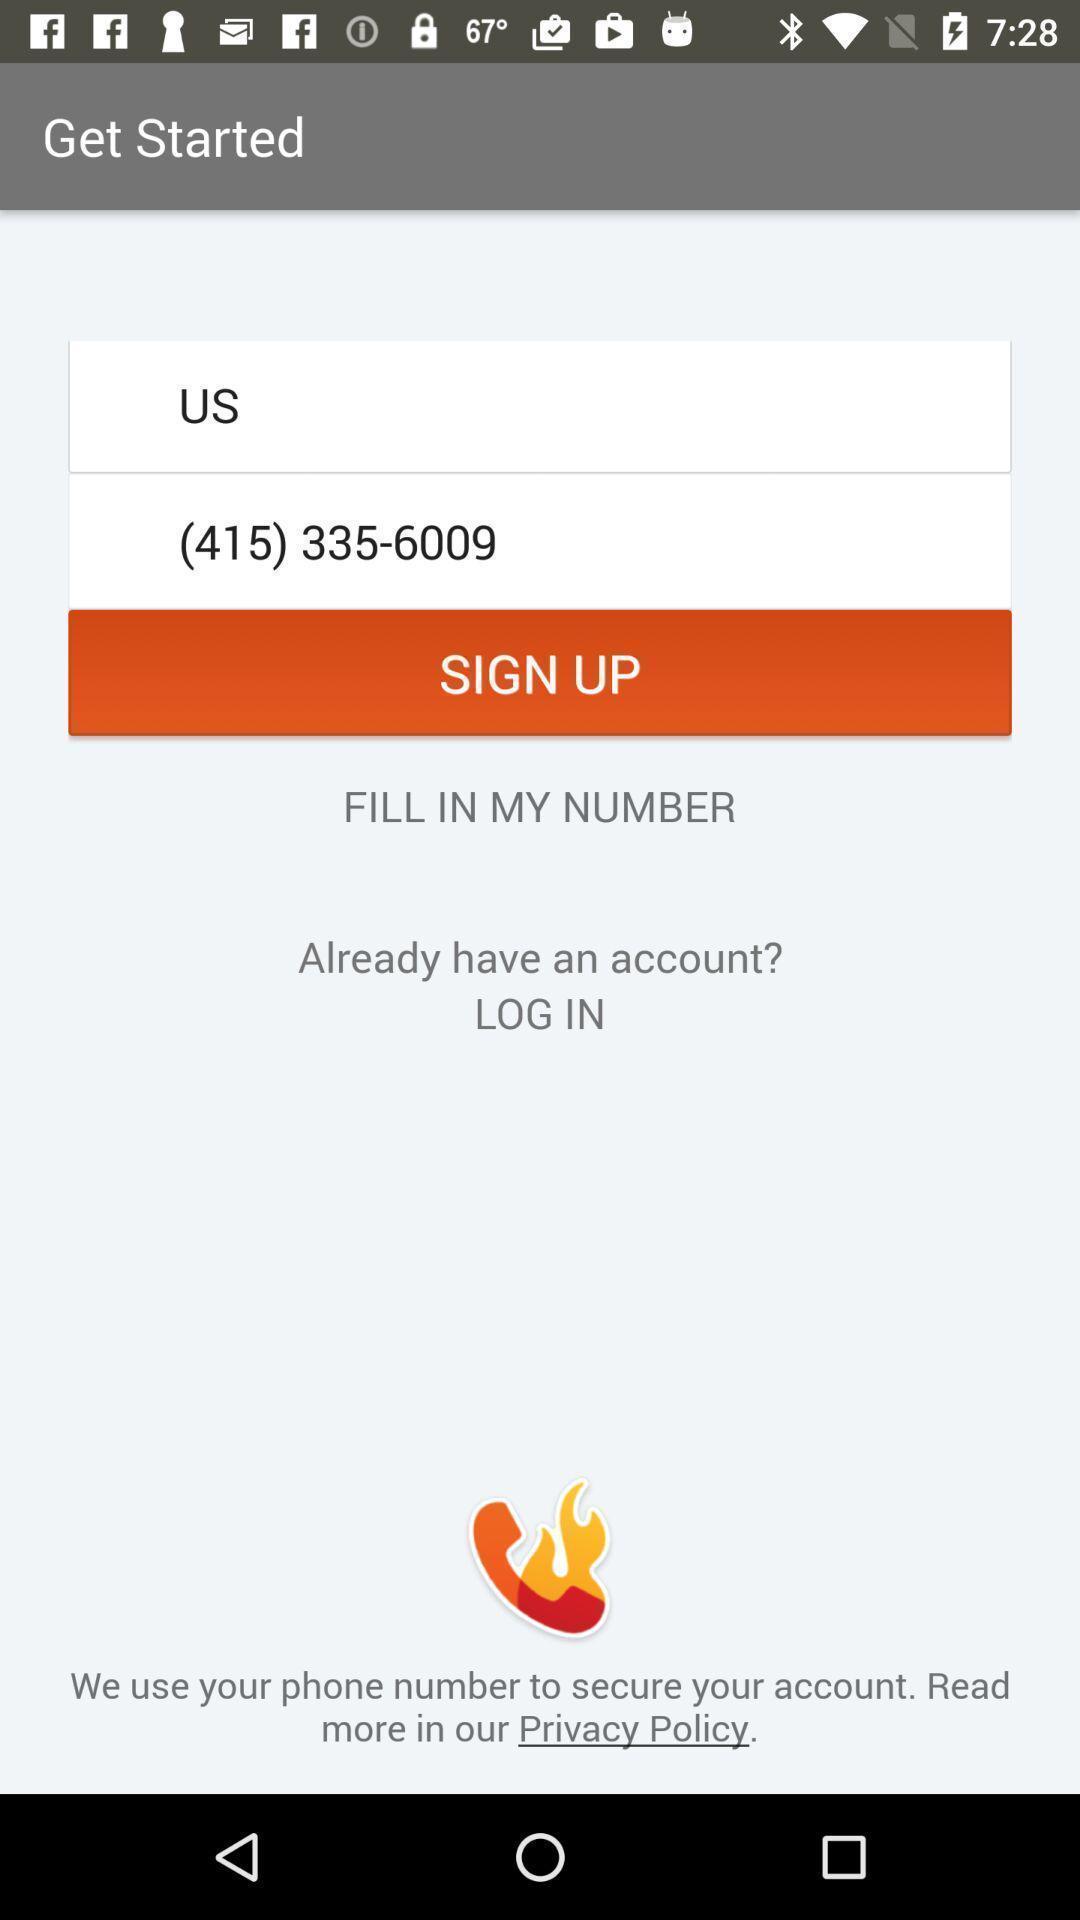Give me a narrative description of this picture. Welcome page with options for a communication based app. 